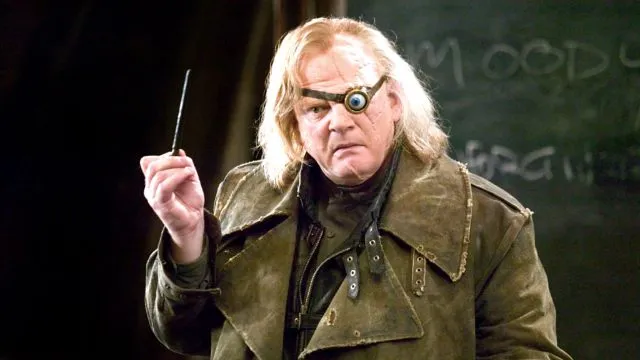What mood does the environment around the character suggest? The dark and minimalistic background creates a somber mood, focusing all attention on the character. This setting can imply a serious or tense moment, possibly reflecting a significant scene where the character's skills or decisions play a crucial role. 